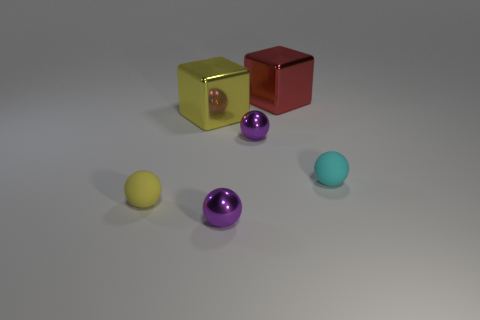Are there fewer red shiny things to the right of the tiny cyan rubber object than shiny objects?
Offer a terse response. Yes. How many other things are there of the same shape as the large yellow thing?
Give a very brief answer. 1. How many things are metallic balls that are behind the small cyan matte object or small things in front of the tiny cyan ball?
Your answer should be compact. 3. What size is the object that is both behind the cyan sphere and in front of the big yellow metal cube?
Your response must be concise. Small. There is a matte thing to the left of the yellow metallic block; is its shape the same as the cyan matte object?
Your answer should be very brief. Yes. There is a yellow object in front of the small cyan matte thing to the right of the yellow thing behind the yellow rubber object; what is its size?
Give a very brief answer. Small. How many things are either large metal cubes or red metal objects?
Give a very brief answer. 2. What shape is the thing that is both to the right of the big yellow block and in front of the tiny cyan matte ball?
Offer a terse response. Sphere. There is a large yellow metallic object; does it have the same shape as the yellow object in front of the tiny cyan thing?
Offer a very short reply. No. Are there any purple spheres on the right side of the large red shiny cube?
Give a very brief answer. No. 